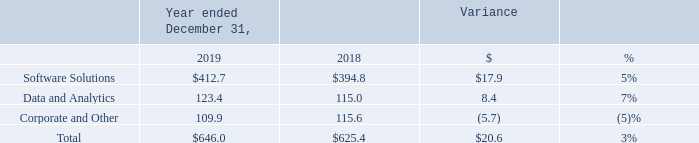Consolidated Financial Results
Operating Expenses
The following table sets forth operating expenses by segment for the periods presented (in millions):
The increase in Operating Expenses was primarily driven by higher net personnel costs, technology-related costs and acquisition-related costs in our Software Solutions segment. The increase in our Data and Analytics segment primarily related to higher net personnel costs and higher data costs related to revenue growth. The decrease in Corporate and Other was primarily driven by lower incentive bonus expense.
What was the main reason for the increase in Operating Expenses? Higher net personnel costs, technology-related costs and acquisition-related costs in our software solutions segment. What was the primary reason for the decrease in Corporate and Other? Lower incentive bonus expense. Which years does the table provide information for the company's operating expenses by segment? 2019, 2018. What was the difference in the percent variance between Software Solutions and Data and Analytics?
Answer scale should be: percent. 7-5
Answer: 2. What was the average revenue from Corporate and Other between 2018 and 2019?
Answer scale should be: million. (109.9+115.6)/2
Answer: 112.75. What was the average  operating expenses between 2018 and 2019?
Answer scale should be: million. (646.0+625.4)/2
Answer: 635.7. 